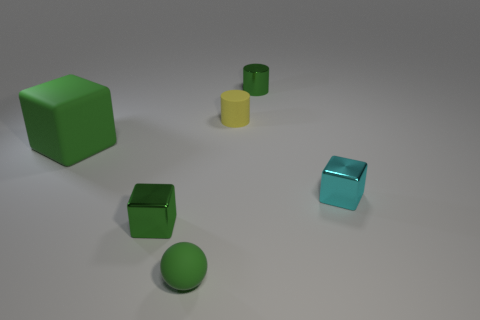Are there the same number of blocks that are behind the green metallic cylinder and small cyan things?
Keep it short and to the point. No. Does the large matte object have the same shape as the tiny cyan shiny thing?
Your answer should be very brief. Yes. Is there anything else that has the same color as the small matte cylinder?
Provide a short and direct response. No. What shape is the small metallic thing that is to the left of the tiny cyan cube and to the right of the small green matte sphere?
Make the answer very short. Cylinder. Are there an equal number of small shiny objects to the right of the matte cylinder and small cyan metallic blocks that are on the left side of the green cylinder?
Your answer should be very brief. No. How many balls are tiny yellow objects or large green rubber objects?
Your response must be concise. 0. How many cylinders have the same material as the big green object?
Give a very brief answer. 1. What is the shape of the rubber thing that is the same color as the big matte cube?
Provide a short and direct response. Sphere. The tiny object that is right of the small yellow cylinder and behind the rubber cube is made of what material?
Give a very brief answer. Metal. What shape is the small green shiny thing behind the large object?
Give a very brief answer. Cylinder. 